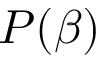Convert formula to latex. <formula><loc_0><loc_0><loc_500><loc_500>P ( \beta )</formula> 